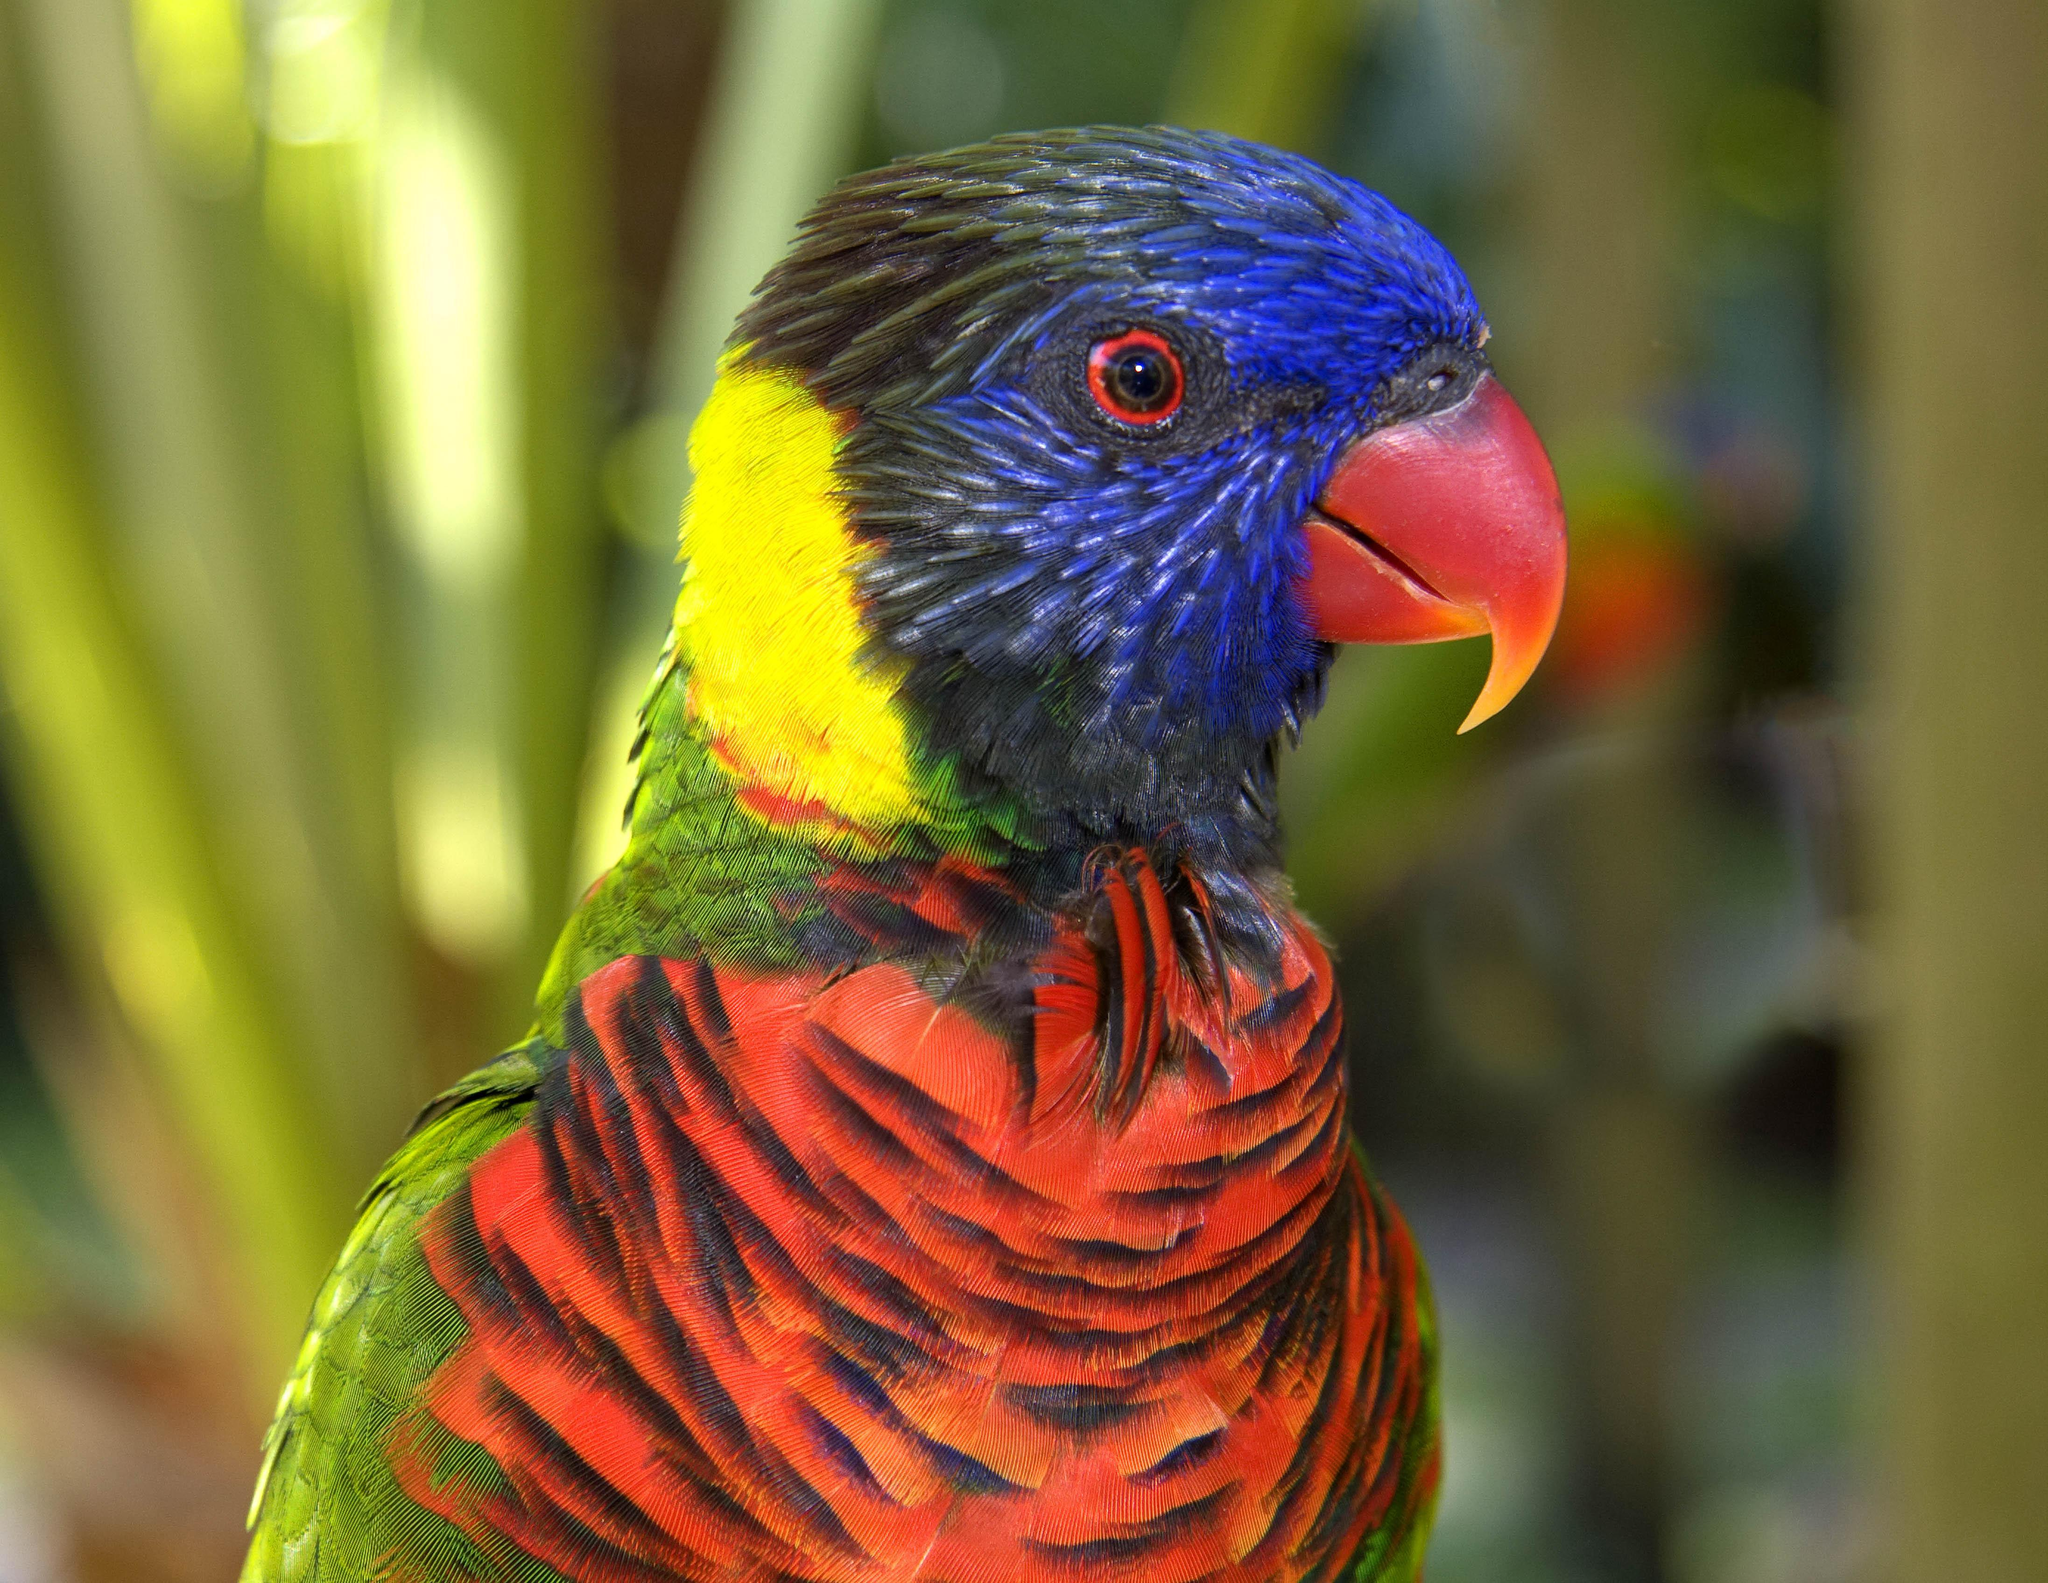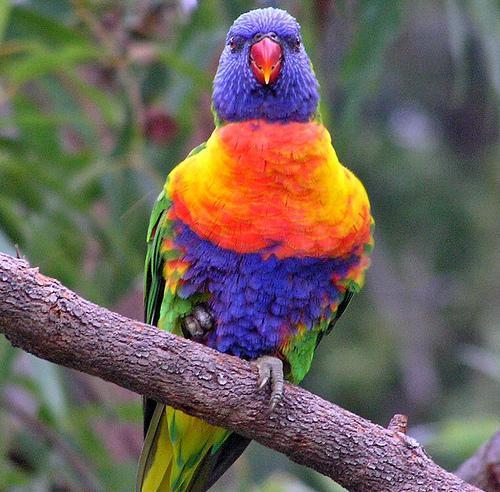The first image is the image on the left, the second image is the image on the right. Evaluate the accuracy of this statement regarding the images: "An image shows exactly one parrot perched upright on a real tree branch.". Is it true? Answer yes or no. Yes. The first image is the image on the left, the second image is the image on the right. For the images displayed, is the sentence "Two birds are perched together in at least one of the images." factually correct? Answer yes or no. No. 